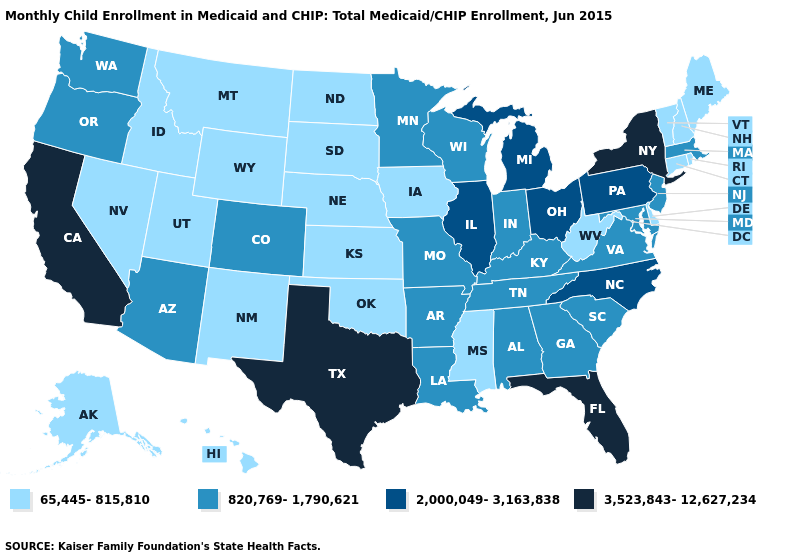Which states have the lowest value in the South?
Keep it brief. Delaware, Mississippi, Oklahoma, West Virginia. What is the lowest value in the MidWest?
Answer briefly. 65,445-815,810. What is the value of Georgia?
Give a very brief answer. 820,769-1,790,621. Which states have the lowest value in the Northeast?
Be succinct. Connecticut, Maine, New Hampshire, Rhode Island, Vermont. What is the highest value in the Northeast ?
Write a very short answer. 3,523,843-12,627,234. What is the lowest value in the South?
Keep it brief. 65,445-815,810. What is the lowest value in the West?
Answer briefly. 65,445-815,810. What is the value of Arkansas?
Concise answer only. 820,769-1,790,621. What is the lowest value in the USA?
Write a very short answer. 65,445-815,810. What is the value of North Carolina?
Short answer required. 2,000,049-3,163,838. Does Oregon have a higher value than New York?
Give a very brief answer. No. What is the highest value in the USA?
Answer briefly. 3,523,843-12,627,234. What is the lowest value in the USA?
Concise answer only. 65,445-815,810. Which states hav the highest value in the MidWest?
Quick response, please. Illinois, Michigan, Ohio. Name the states that have a value in the range 2,000,049-3,163,838?
Keep it brief. Illinois, Michigan, North Carolina, Ohio, Pennsylvania. 